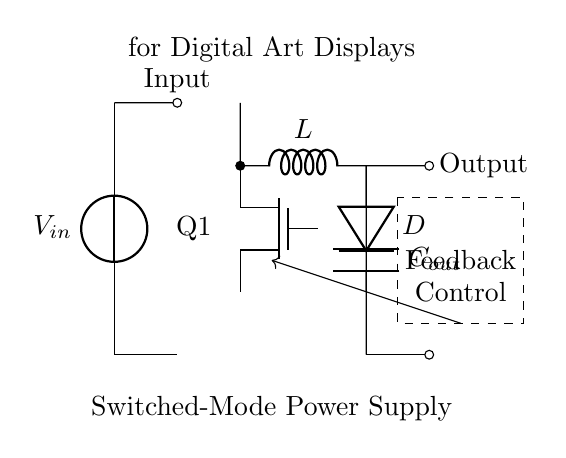What is the input component of this circuit? The input component is designated by the voltage source symbol (vsource), which represents the power supply or input voltage for the circuit.
Answer: Voltage source What does the inductor represent in this circuit? The inductor (L) is responsible for storing energy in a magnetic field when current flows through it, and its placement in the circuit indicates that it's used for energy transfer in the switched-mode power supply process.
Answer: Energy storage How many main components are identifiable in this circuit? The main components include the voltage source, a MOSFET switch, an inductor, a diode, and an output capacitor. Counting these gives a total of five components.
Answer: Five components What does the dashed rectangle signify in this circuit? The dashed rectangle indicates a feedback and control mechanism, which helps regulate the output voltage or current by comparing it to a reference value and making adjustments.
Answer: Feedback and control What type of switch is used in this circuit? The switch used in this circuit is a MOSFET, specifically indicated by the symbol Tnmos, which is commonly utilized for efficient switching in power conversion applications.
Answer: MOSFET What is the purpose of the output capacitor in this circuit? The output capacitor (Cout) smooths the output voltage by filtering out any ripples in the voltage signal, ensuring a stable power supply for the digital art displays.
Answer: Voltage smoothing What is the output connection labeled as? The output connection is labeled as "Output," which indicates where the regulated voltage or current is delivered to the load (in this case, the digital art displays).
Answer: Output 